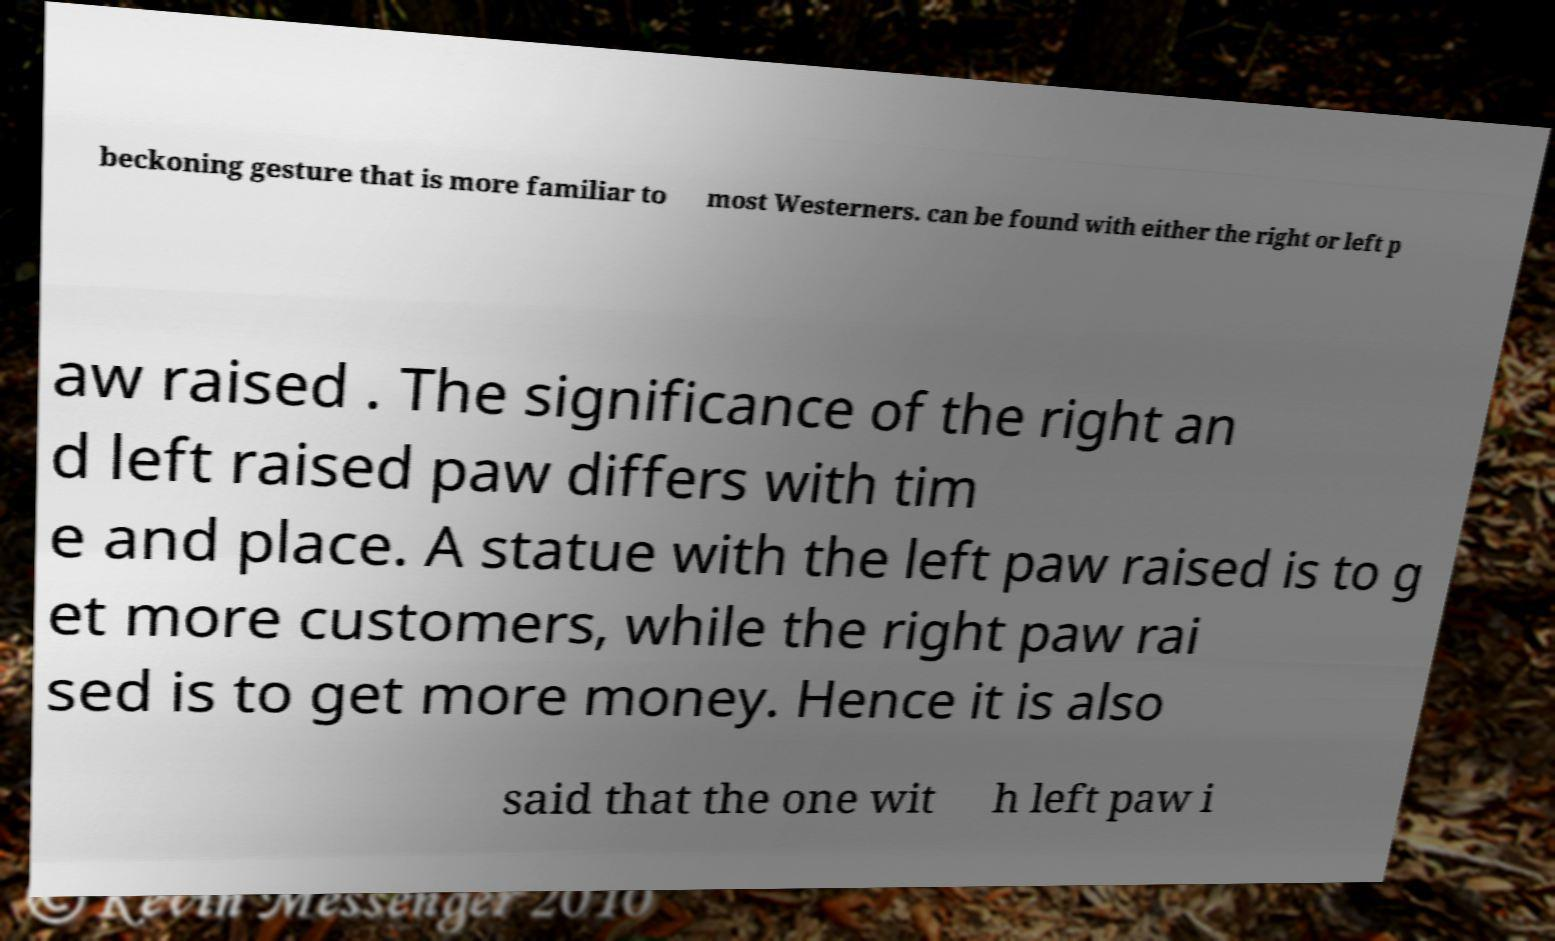Please identify and transcribe the text found in this image. beckoning gesture that is more familiar to most Westerners. can be found with either the right or left p aw raised . The significance of the right an d left raised paw differs with tim e and place. A statue with the left paw raised is to g et more customers, while the right paw rai sed is to get more money. Hence it is also said that the one wit h left paw i 